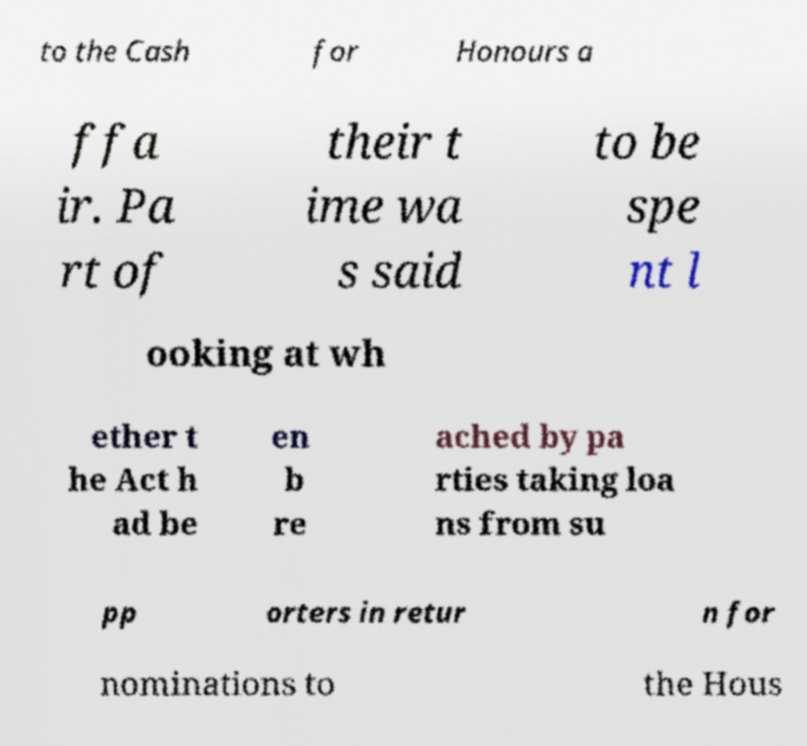Could you assist in decoding the text presented in this image and type it out clearly? to the Cash for Honours a ffa ir. Pa rt of their t ime wa s said to be spe nt l ooking at wh ether t he Act h ad be en b re ached by pa rties taking loa ns from su pp orters in retur n for nominations to the Hous 